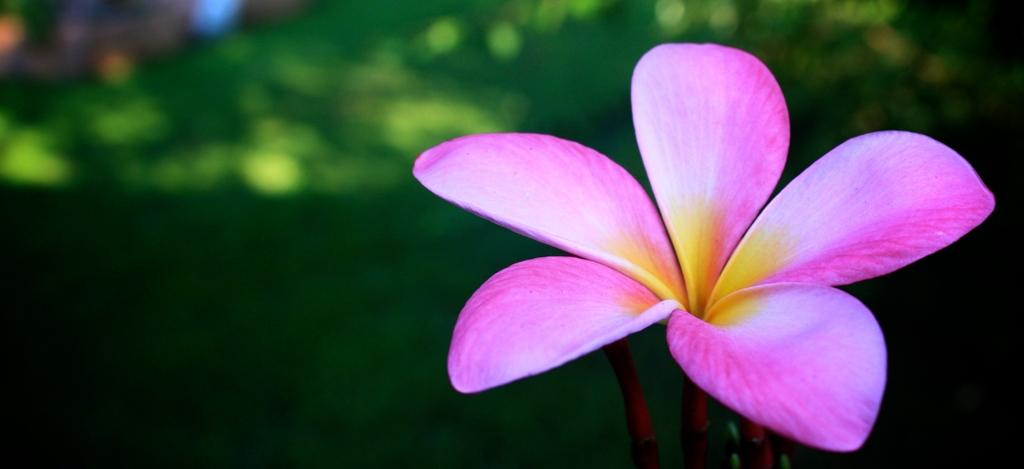What type of flower is on the right side of the image? There is a pink flower on the right side of the image. What color is the background of the image? The background of the image is green. What channel is the animal watching on the television in the image? There is no television or animal present in the image; it only features a pink flower and a green background. 